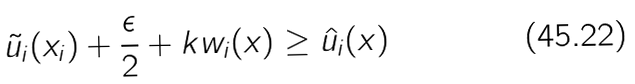Convert formula to latex. <formula><loc_0><loc_0><loc_500><loc_500>\tilde { u } _ { i } ( x _ { i } ) + \frac { \epsilon } { 2 } + k w _ { i } ( x ) \geq \hat { u } _ { i } ( x )</formula> 